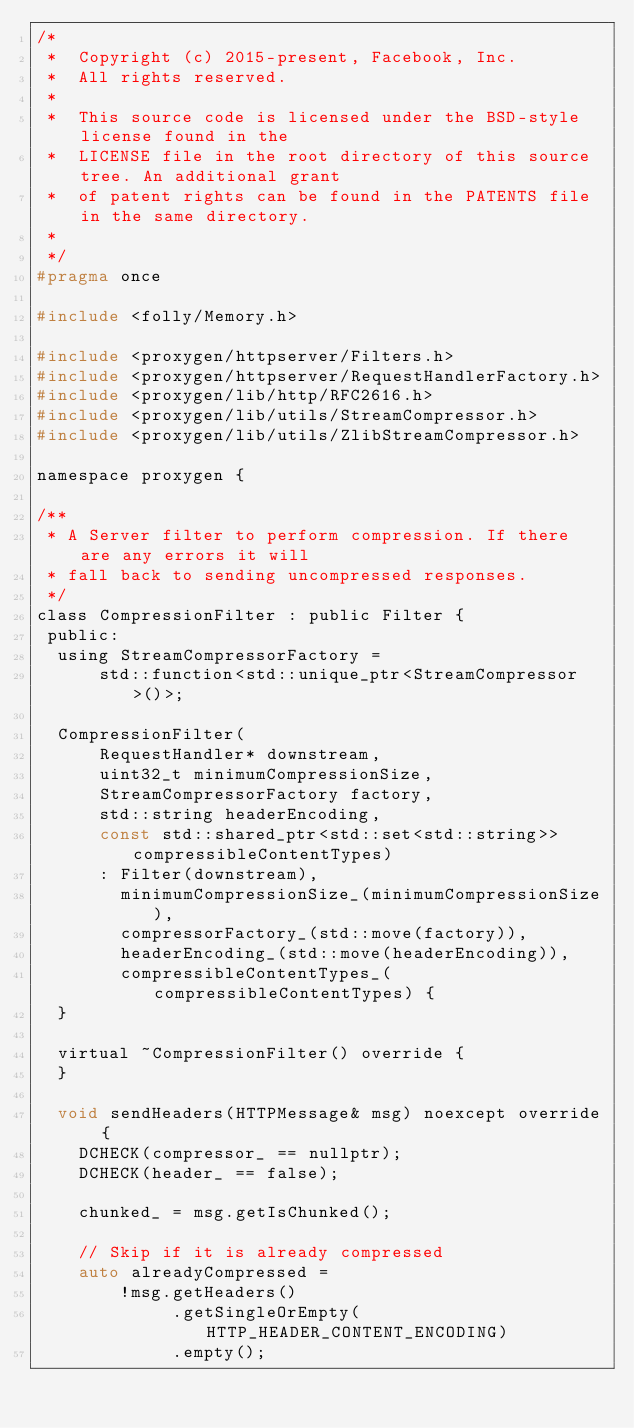<code> <loc_0><loc_0><loc_500><loc_500><_C_>/*
 *  Copyright (c) 2015-present, Facebook, Inc.
 *  All rights reserved.
 *
 *  This source code is licensed under the BSD-style license found in the
 *  LICENSE file in the root directory of this source tree. An additional grant
 *  of patent rights can be found in the PATENTS file in the same directory.
 *
 */
#pragma once

#include <folly/Memory.h>

#include <proxygen/httpserver/Filters.h>
#include <proxygen/httpserver/RequestHandlerFactory.h>
#include <proxygen/lib/http/RFC2616.h>
#include <proxygen/lib/utils/StreamCompressor.h>
#include <proxygen/lib/utils/ZlibStreamCompressor.h>

namespace proxygen {

/**
 * A Server filter to perform compression. If there are any errors it will
 * fall back to sending uncompressed responses.
 */
class CompressionFilter : public Filter {
 public:
  using StreamCompressorFactory =
      std::function<std::unique_ptr<StreamCompressor>()>;

  CompressionFilter(
      RequestHandler* downstream,
      uint32_t minimumCompressionSize,
      StreamCompressorFactory factory,
      std::string headerEncoding,
      const std::shared_ptr<std::set<std::string>> compressibleContentTypes)
      : Filter(downstream),
        minimumCompressionSize_(minimumCompressionSize),
        compressorFactory_(std::move(factory)),
        headerEncoding_(std::move(headerEncoding)),
        compressibleContentTypes_(compressibleContentTypes) {
  }

  virtual ~CompressionFilter() override {
  }

  void sendHeaders(HTTPMessage& msg) noexcept override {
    DCHECK(compressor_ == nullptr);
    DCHECK(header_ == false);

    chunked_ = msg.getIsChunked();

    // Skip if it is already compressed
    auto alreadyCompressed =
        !msg.getHeaders()
             .getSingleOrEmpty(HTTP_HEADER_CONTENT_ENCODING)
             .empty();
</code> 